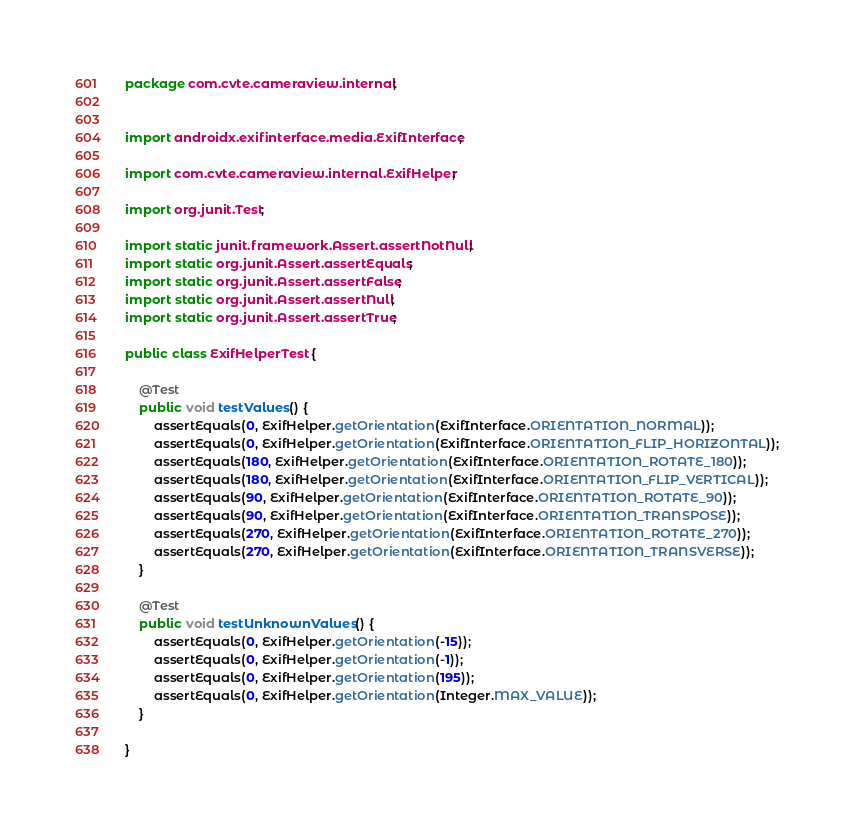Convert code to text. <code><loc_0><loc_0><loc_500><loc_500><_Java_>package com.cvte.cameraview.internal;


import androidx.exifinterface.media.ExifInterface;

import com.cvte.cameraview.internal.ExifHelper;

import org.junit.Test;

import static junit.framework.Assert.assertNotNull;
import static org.junit.Assert.assertEquals;
import static org.junit.Assert.assertFalse;
import static org.junit.Assert.assertNull;
import static org.junit.Assert.assertTrue;

public class ExifHelperTest {

    @Test
    public void testValues() {
        assertEquals(0, ExifHelper.getOrientation(ExifInterface.ORIENTATION_NORMAL));
        assertEquals(0, ExifHelper.getOrientation(ExifInterface.ORIENTATION_FLIP_HORIZONTAL));
        assertEquals(180, ExifHelper.getOrientation(ExifInterface.ORIENTATION_ROTATE_180));
        assertEquals(180, ExifHelper.getOrientation(ExifInterface.ORIENTATION_FLIP_VERTICAL));
        assertEquals(90, ExifHelper.getOrientation(ExifInterface.ORIENTATION_ROTATE_90));
        assertEquals(90, ExifHelper.getOrientation(ExifInterface.ORIENTATION_TRANSPOSE));
        assertEquals(270, ExifHelper.getOrientation(ExifInterface.ORIENTATION_ROTATE_270));
        assertEquals(270, ExifHelper.getOrientation(ExifInterface.ORIENTATION_TRANSVERSE));
    }

    @Test
    public void testUnknownValues() {
        assertEquals(0, ExifHelper.getOrientation(-15));
        assertEquals(0, ExifHelper.getOrientation(-1));
        assertEquals(0, ExifHelper.getOrientation(195));
        assertEquals(0, ExifHelper.getOrientation(Integer.MAX_VALUE));
    }

}
</code> 